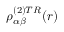<formula> <loc_0><loc_0><loc_500><loc_500>\rho _ { \alpha \beta } ^ { ( 2 ) T R } ( r )</formula> 